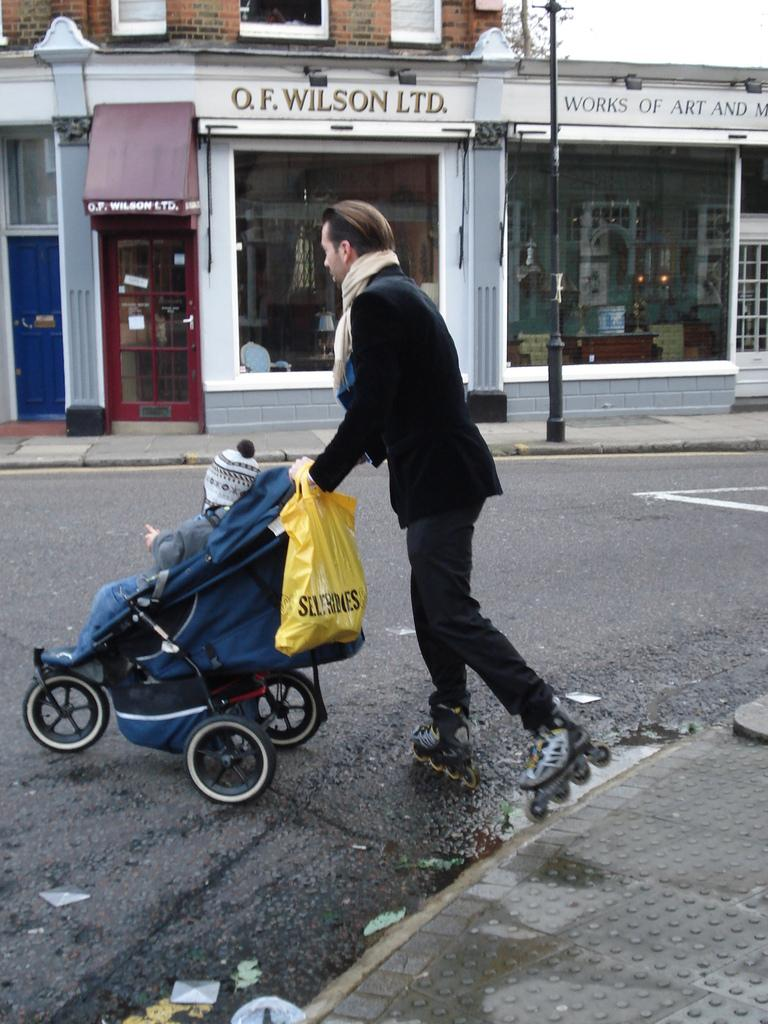Who or what is present in the image? There is a person in the image. What type of shoes is the person wearing? The person is wearing skate shoes. What object is the person carrying? The person is carrying a baby carriage. What type of tent can be seen in the background of the image? There is no tent present in the image. Can you tell me how many goats are visible in the image? There are no goats present in the image. 